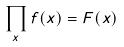Convert formula to latex. <formula><loc_0><loc_0><loc_500><loc_500>\prod _ { x } f ( x ) = F ( x )</formula> 